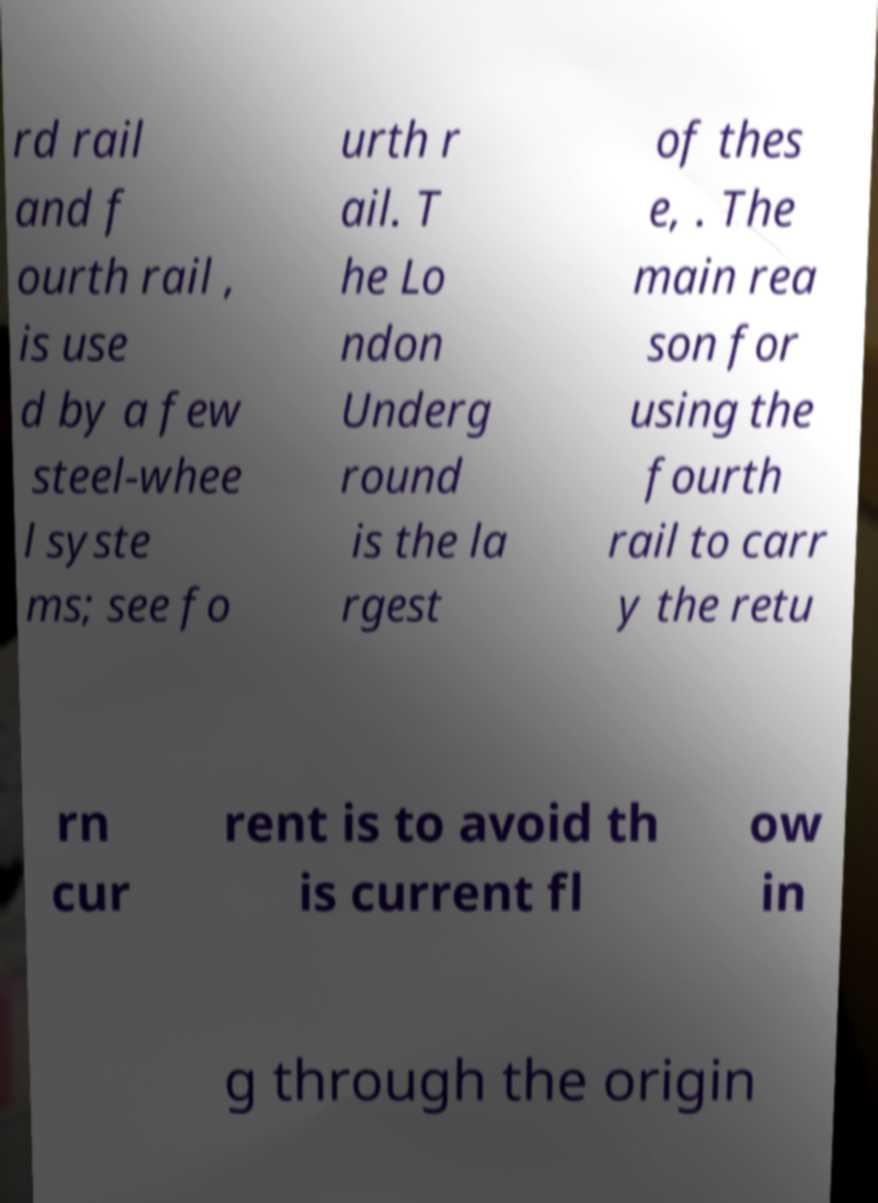Can you read and provide the text displayed in the image?This photo seems to have some interesting text. Can you extract and type it out for me? rd rail and f ourth rail , is use d by a few steel-whee l syste ms; see fo urth r ail. T he Lo ndon Underg round is the la rgest of thes e, . The main rea son for using the fourth rail to carr y the retu rn cur rent is to avoid th is current fl ow in g through the origin 